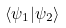<formula> <loc_0><loc_0><loc_500><loc_500>\langle \psi _ { 1 } | \psi _ { 2 } \rangle</formula> 